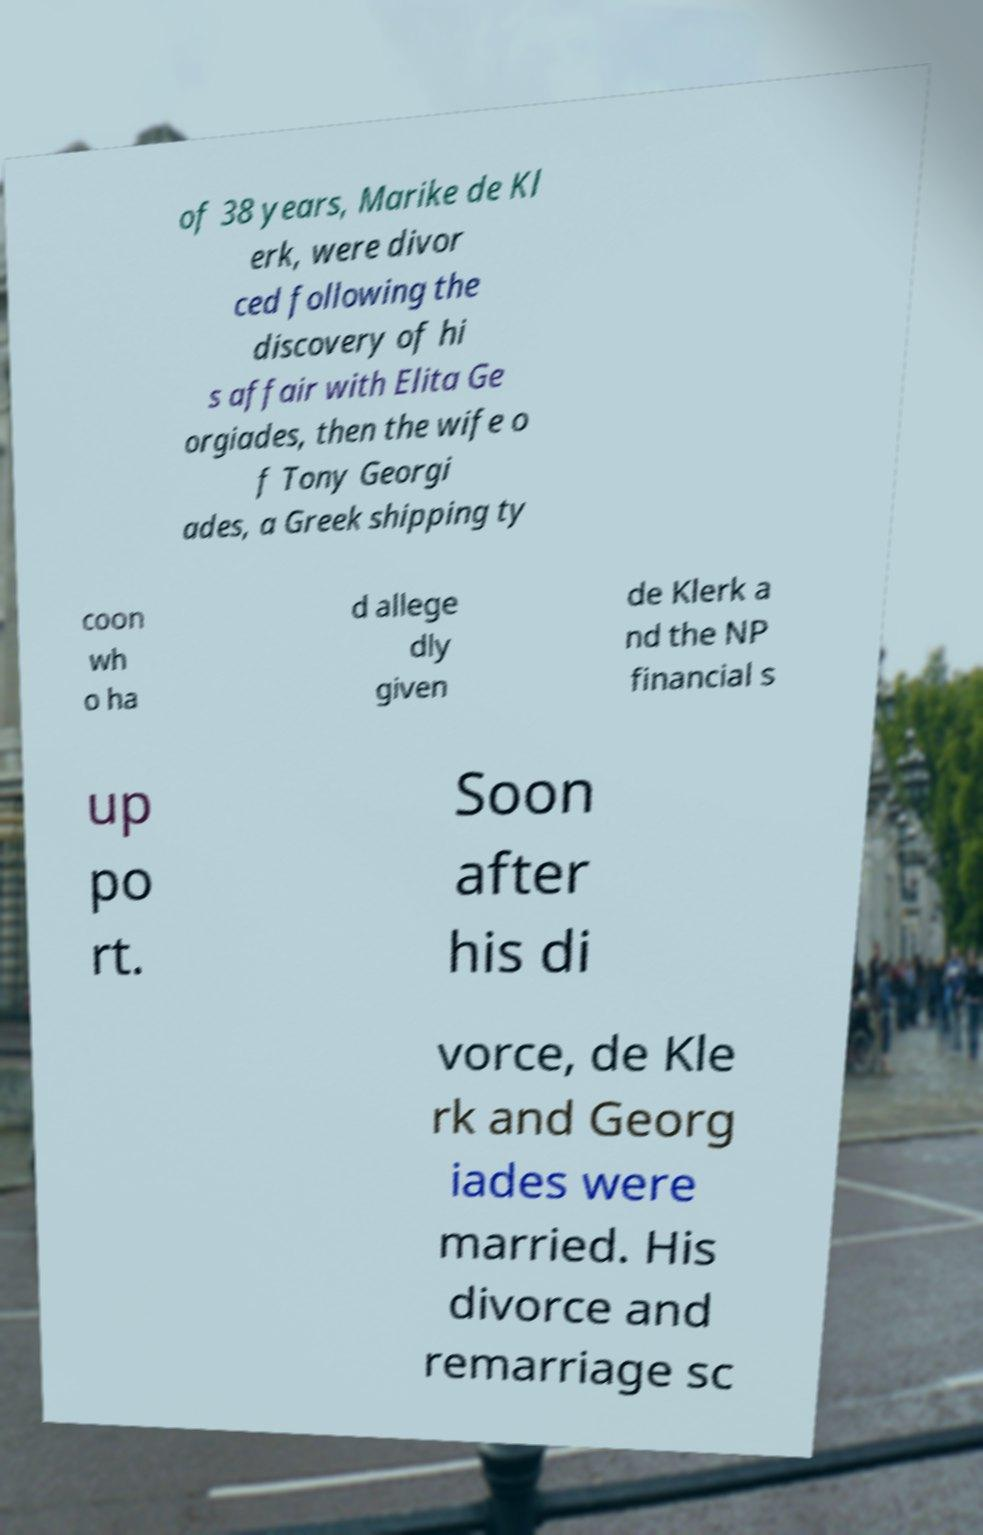Please identify and transcribe the text found in this image. of 38 years, Marike de Kl erk, were divor ced following the discovery of hi s affair with Elita Ge orgiades, then the wife o f Tony Georgi ades, a Greek shipping ty coon wh o ha d allege dly given de Klerk a nd the NP financial s up po rt. Soon after his di vorce, de Kle rk and Georg iades were married. His divorce and remarriage sc 